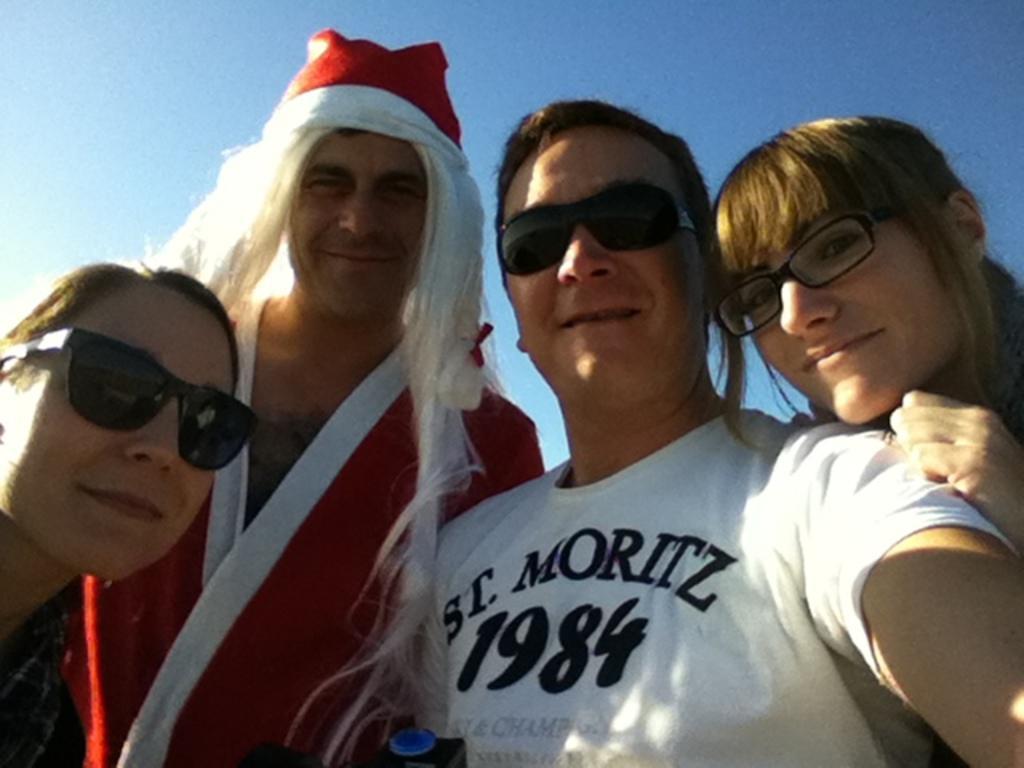Please provide a concise description of this image. On the left side, there is a person wearing sunglasses near a person who is in red color dress standing and smiling. On the right side, there is a woman wearing spectacle and placing a hand on the shoulder of a person who is in white color t-shirt and is smiling. 